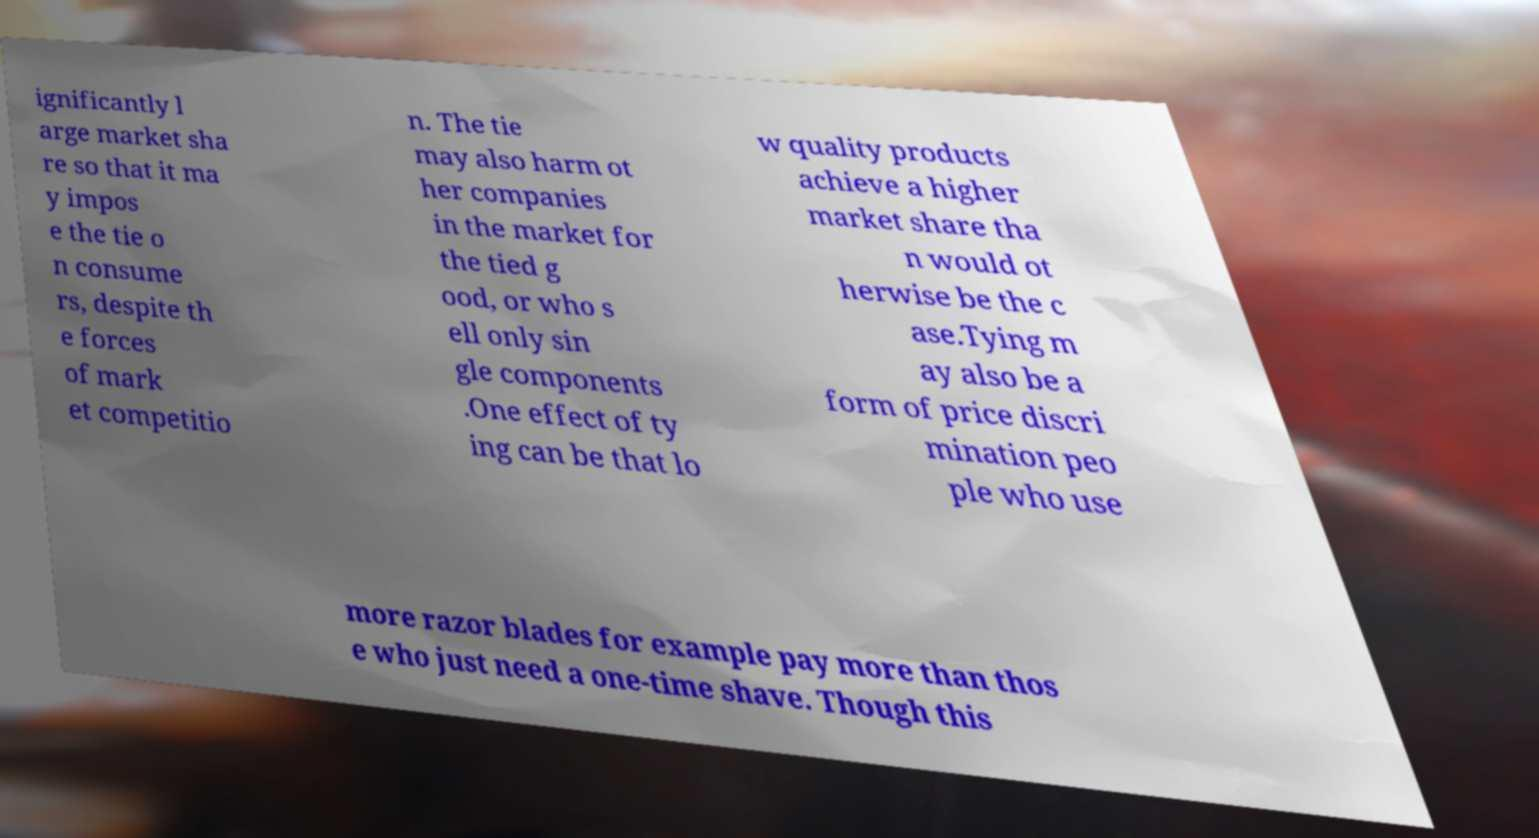Could you assist in decoding the text presented in this image and type it out clearly? ignificantly l arge market sha re so that it ma y impos e the tie o n consume rs, despite th e forces of mark et competitio n. The tie may also harm ot her companies in the market for the tied g ood, or who s ell only sin gle components .One effect of ty ing can be that lo w quality products achieve a higher market share tha n would ot herwise be the c ase.Tying m ay also be a form of price discri mination peo ple who use more razor blades for example pay more than thos e who just need a one-time shave. Though this 